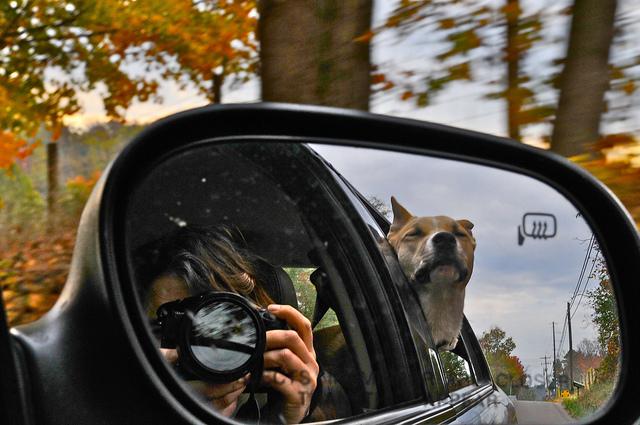Is this the work of a professional photographer?
Concise answer only. No. Is this a happy animal?
Answer briefly. Yes. Where are the reflections?
Short answer required. Mirror. Is the dog's tongue hanging out?
Write a very short answer. No. Is the dog trying to jump out of the car?
Short answer required. No. 